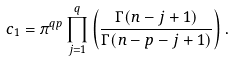<formula> <loc_0><loc_0><loc_500><loc_500>c _ { 1 } & = \pi ^ { q p } \prod _ { j = 1 } ^ { q } \left ( \frac { \Gamma ( n - j + 1 ) } { \Gamma ( n - p - j + 1 ) } \right ) .</formula> 